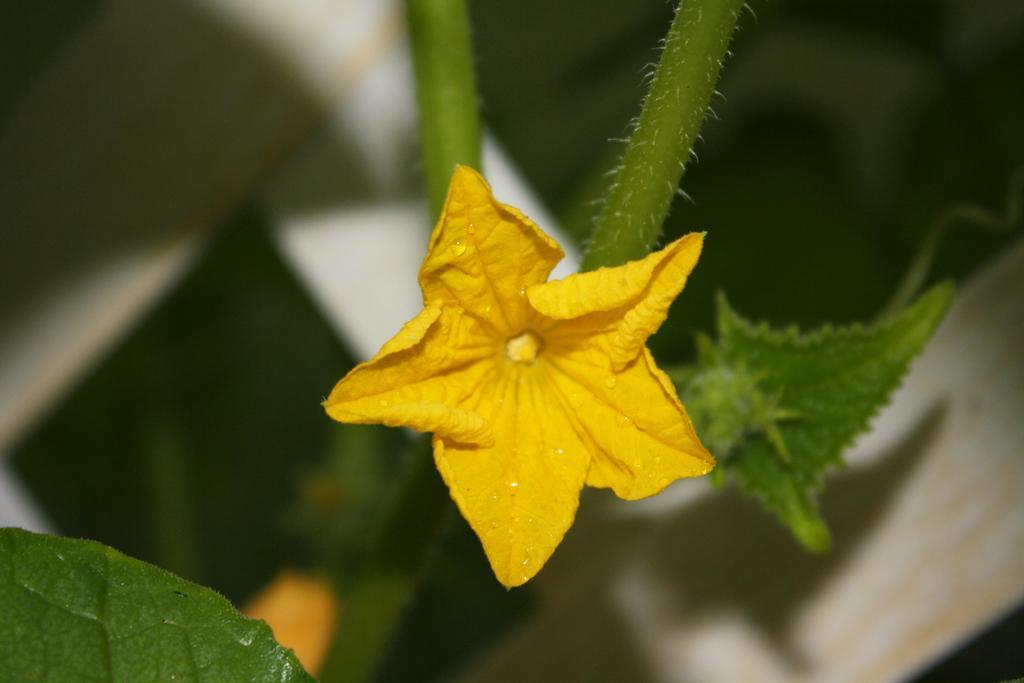How would you summarize this image in a sentence or two? In this image there is a flower and there are leaves and there is a plant and the background is blurry. 